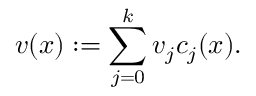Convert formula to latex. <formula><loc_0><loc_0><loc_500><loc_500>v ( x ) \colon = \sum _ { j = 0 } ^ { k } v _ { j } c _ { j } ( x ) .</formula> 